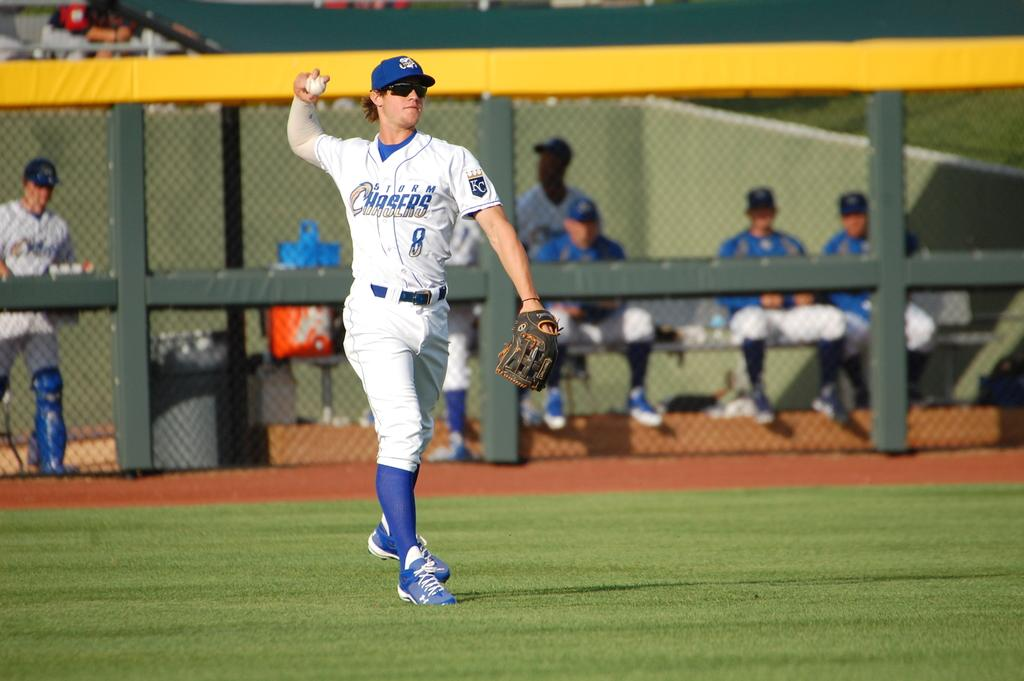Provide a one-sentence caption for the provided image. The Storm Chasers player is about to throw the ball. 